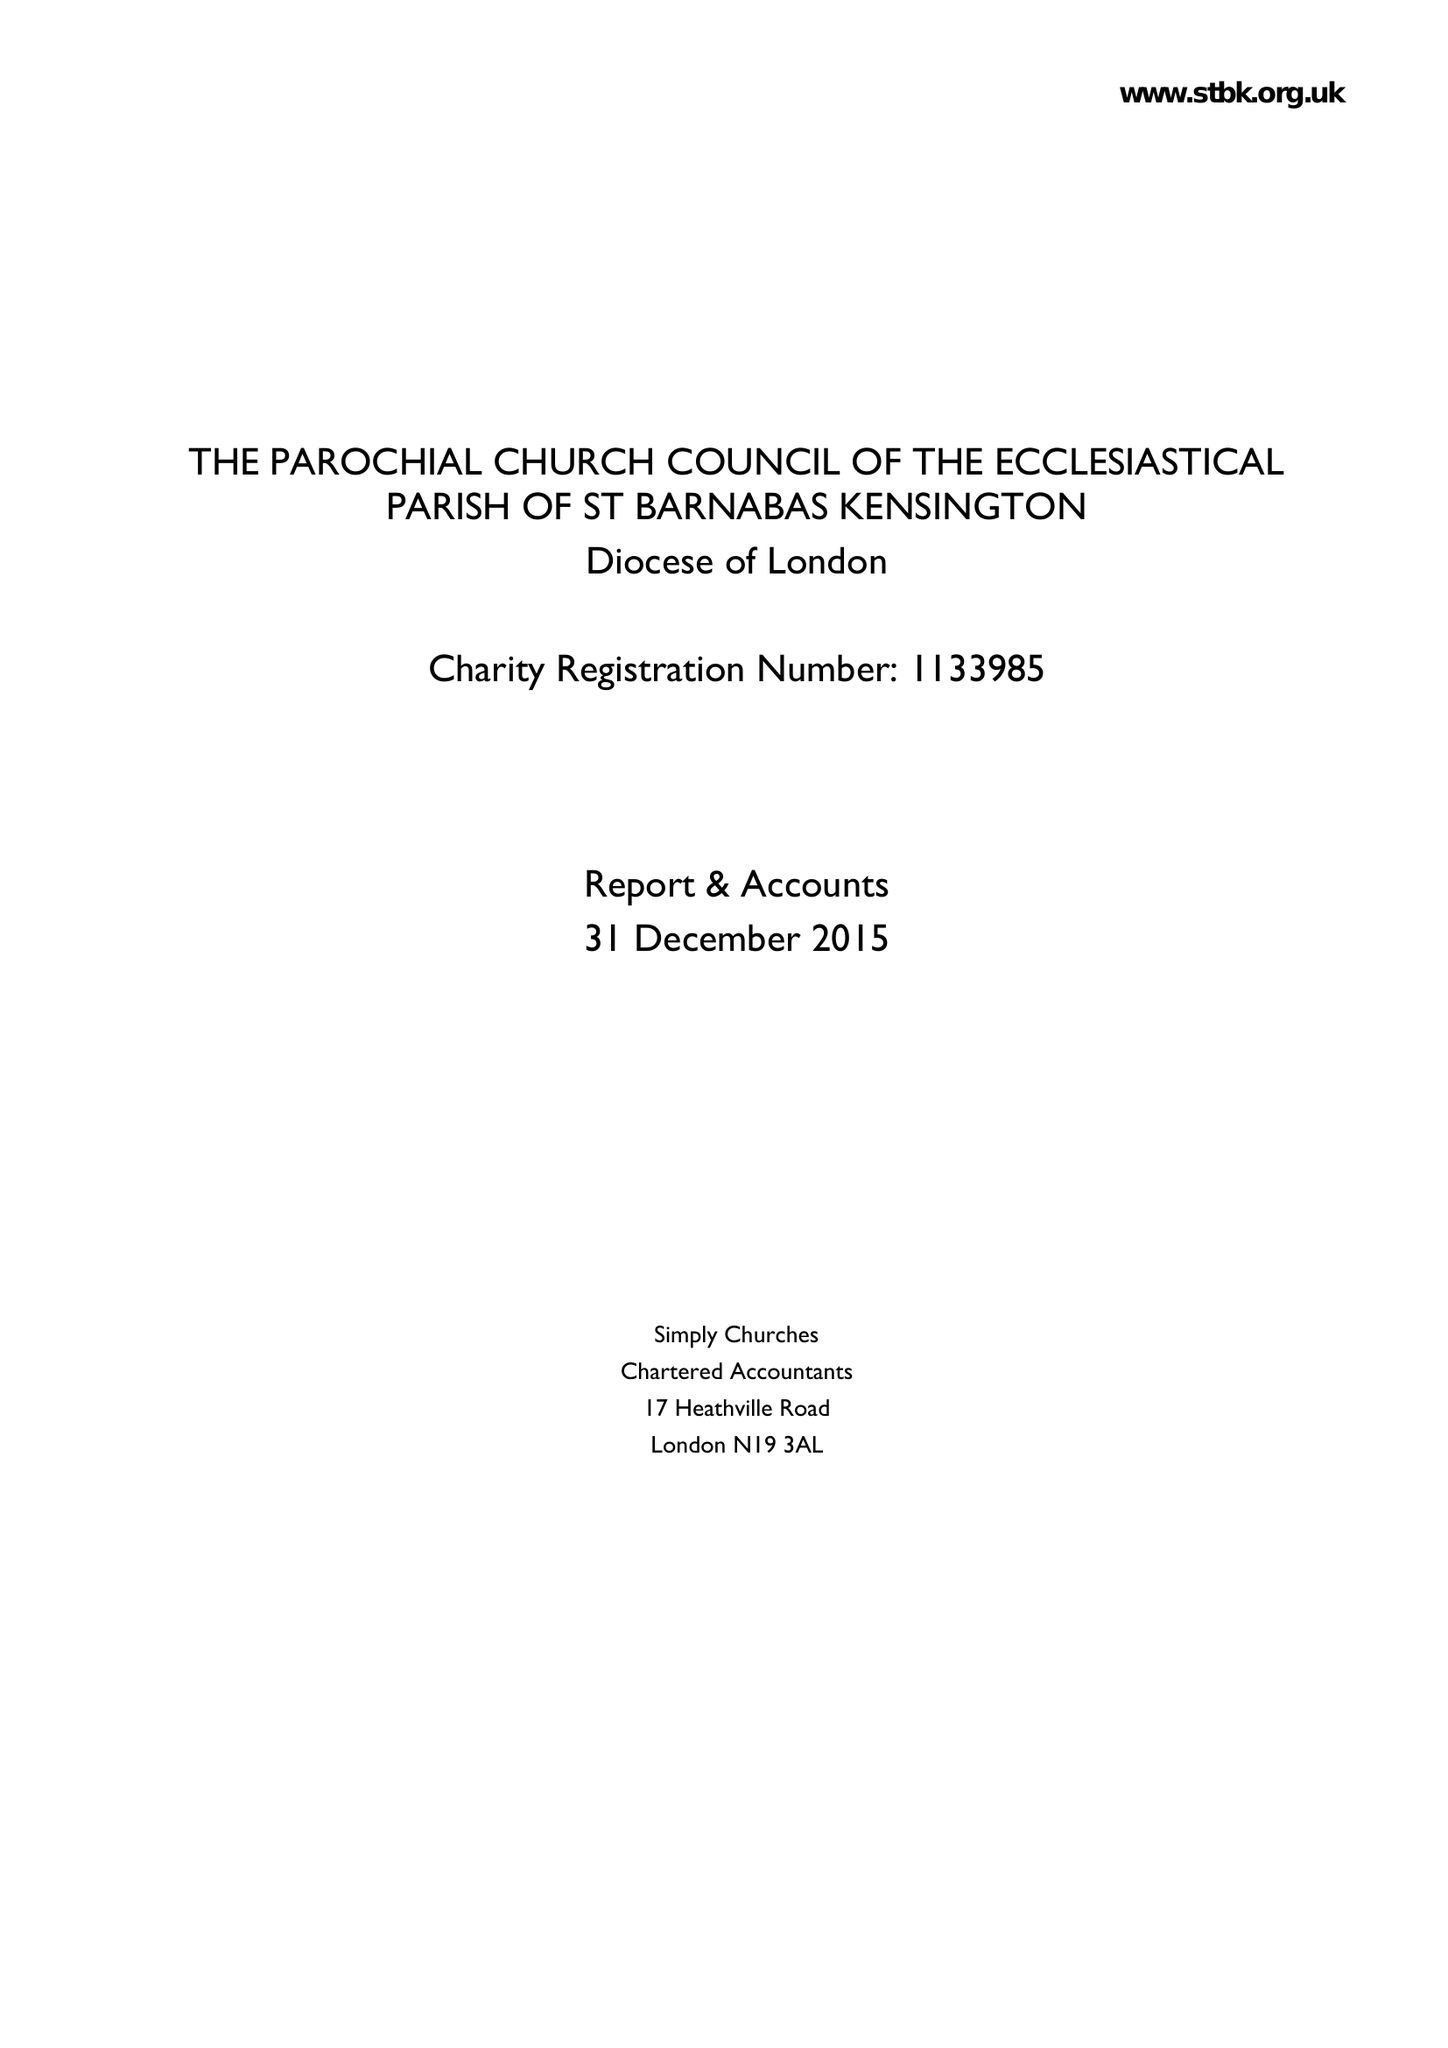What is the value for the address__street_line?
Answer the question using a single word or phrase. 23 ADDISON ROAD 